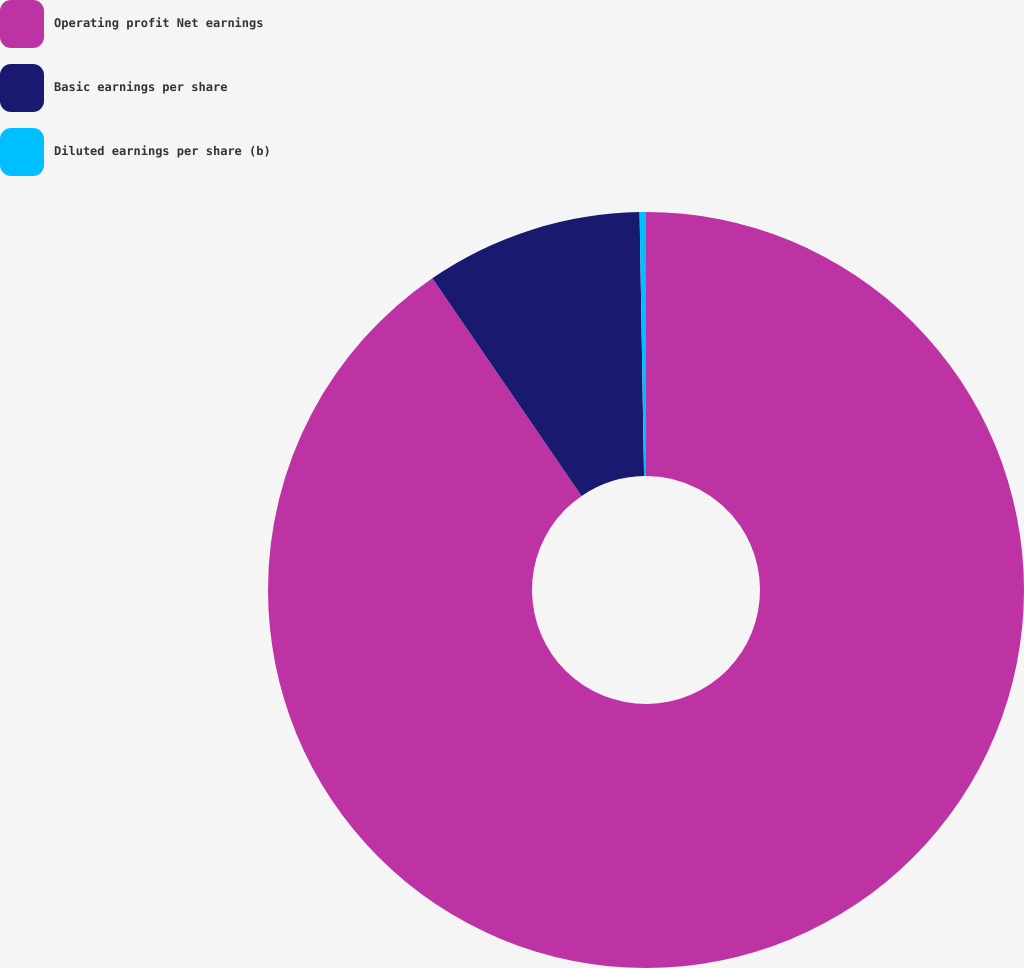<chart> <loc_0><loc_0><loc_500><loc_500><pie_chart><fcel>Operating profit Net earnings<fcel>Basic earnings per share<fcel>Diluted earnings per share (b)<nl><fcel>90.43%<fcel>9.29%<fcel>0.27%<nl></chart> 